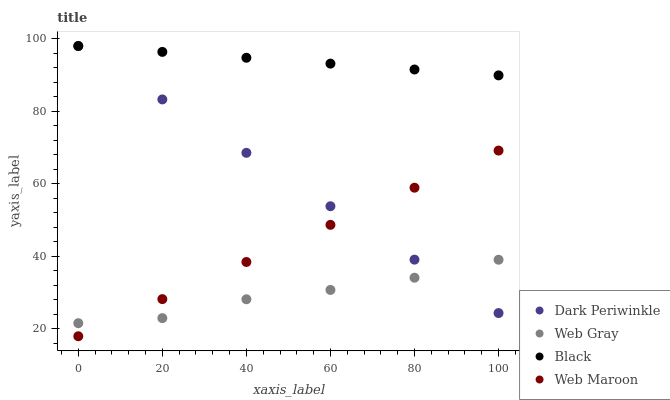Does Web Gray have the minimum area under the curve?
Answer yes or no. Yes. Does Black have the maximum area under the curve?
Answer yes or no. Yes. Does Black have the minimum area under the curve?
Answer yes or no. No. Does Web Gray have the maximum area under the curve?
Answer yes or no. No. Is Dark Periwinkle the smoothest?
Answer yes or no. Yes. Is Web Gray the roughest?
Answer yes or no. Yes. Is Black the smoothest?
Answer yes or no. No. Is Black the roughest?
Answer yes or no. No. Does Web Maroon have the lowest value?
Answer yes or no. Yes. Does Web Gray have the lowest value?
Answer yes or no. No. Does Dark Periwinkle have the highest value?
Answer yes or no. Yes. Does Web Gray have the highest value?
Answer yes or no. No. Is Web Gray less than Black?
Answer yes or no. Yes. Is Black greater than Web Gray?
Answer yes or no. Yes. Does Dark Periwinkle intersect Black?
Answer yes or no. Yes. Is Dark Periwinkle less than Black?
Answer yes or no. No. Is Dark Periwinkle greater than Black?
Answer yes or no. No. Does Web Gray intersect Black?
Answer yes or no. No. 